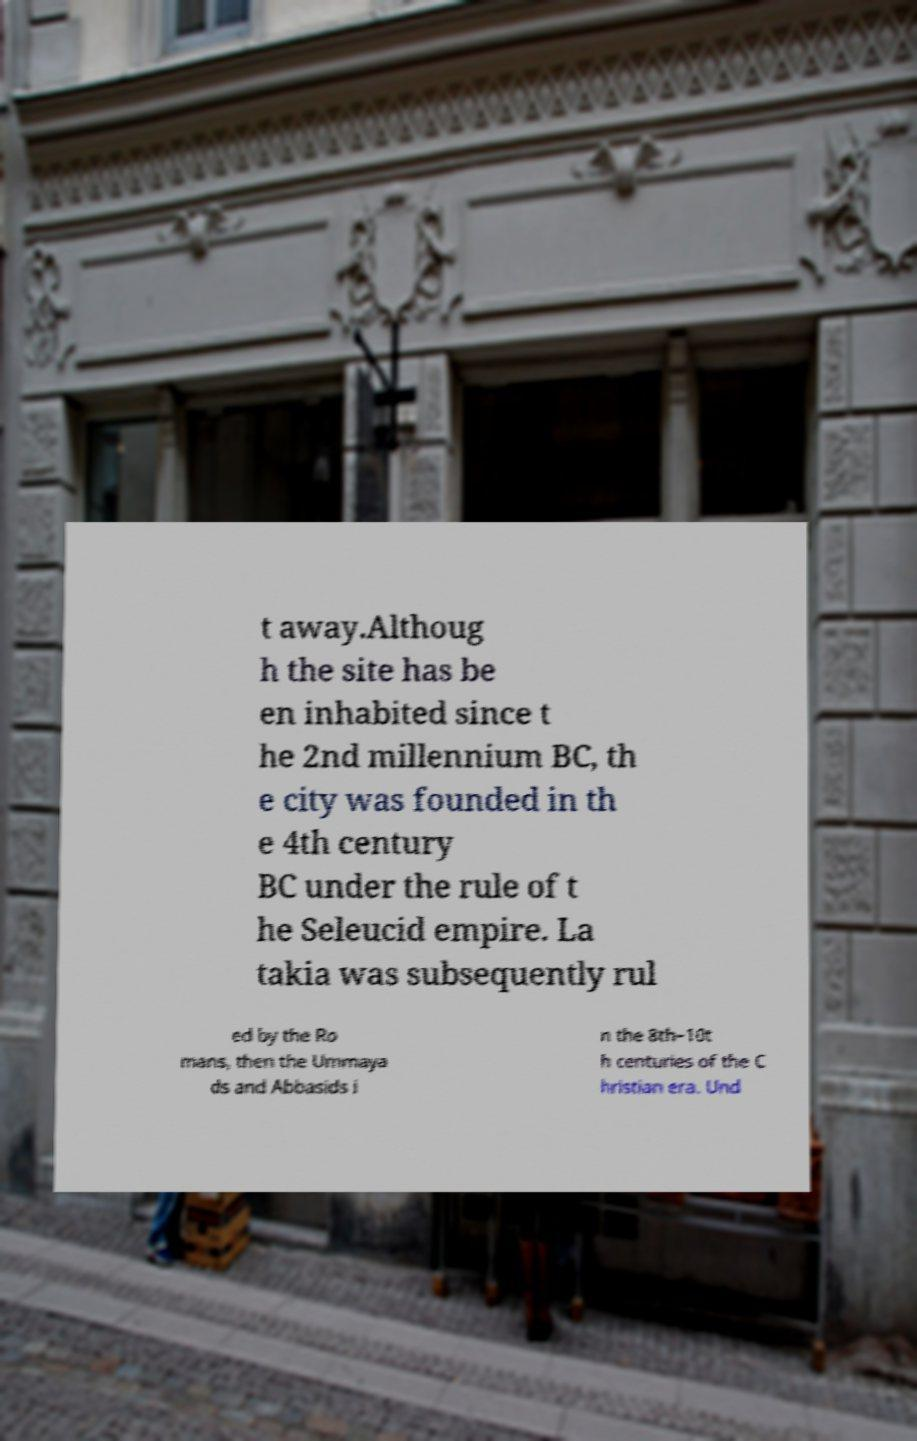Could you assist in decoding the text presented in this image and type it out clearly? t away.Althoug h the site has be en inhabited since t he 2nd millennium BC, th e city was founded in th e 4th century BC under the rule of t he Seleucid empire. La takia was subsequently rul ed by the Ro mans, then the Ummaya ds and Abbasids i n the 8th–10t h centuries of the C hristian era. Und 